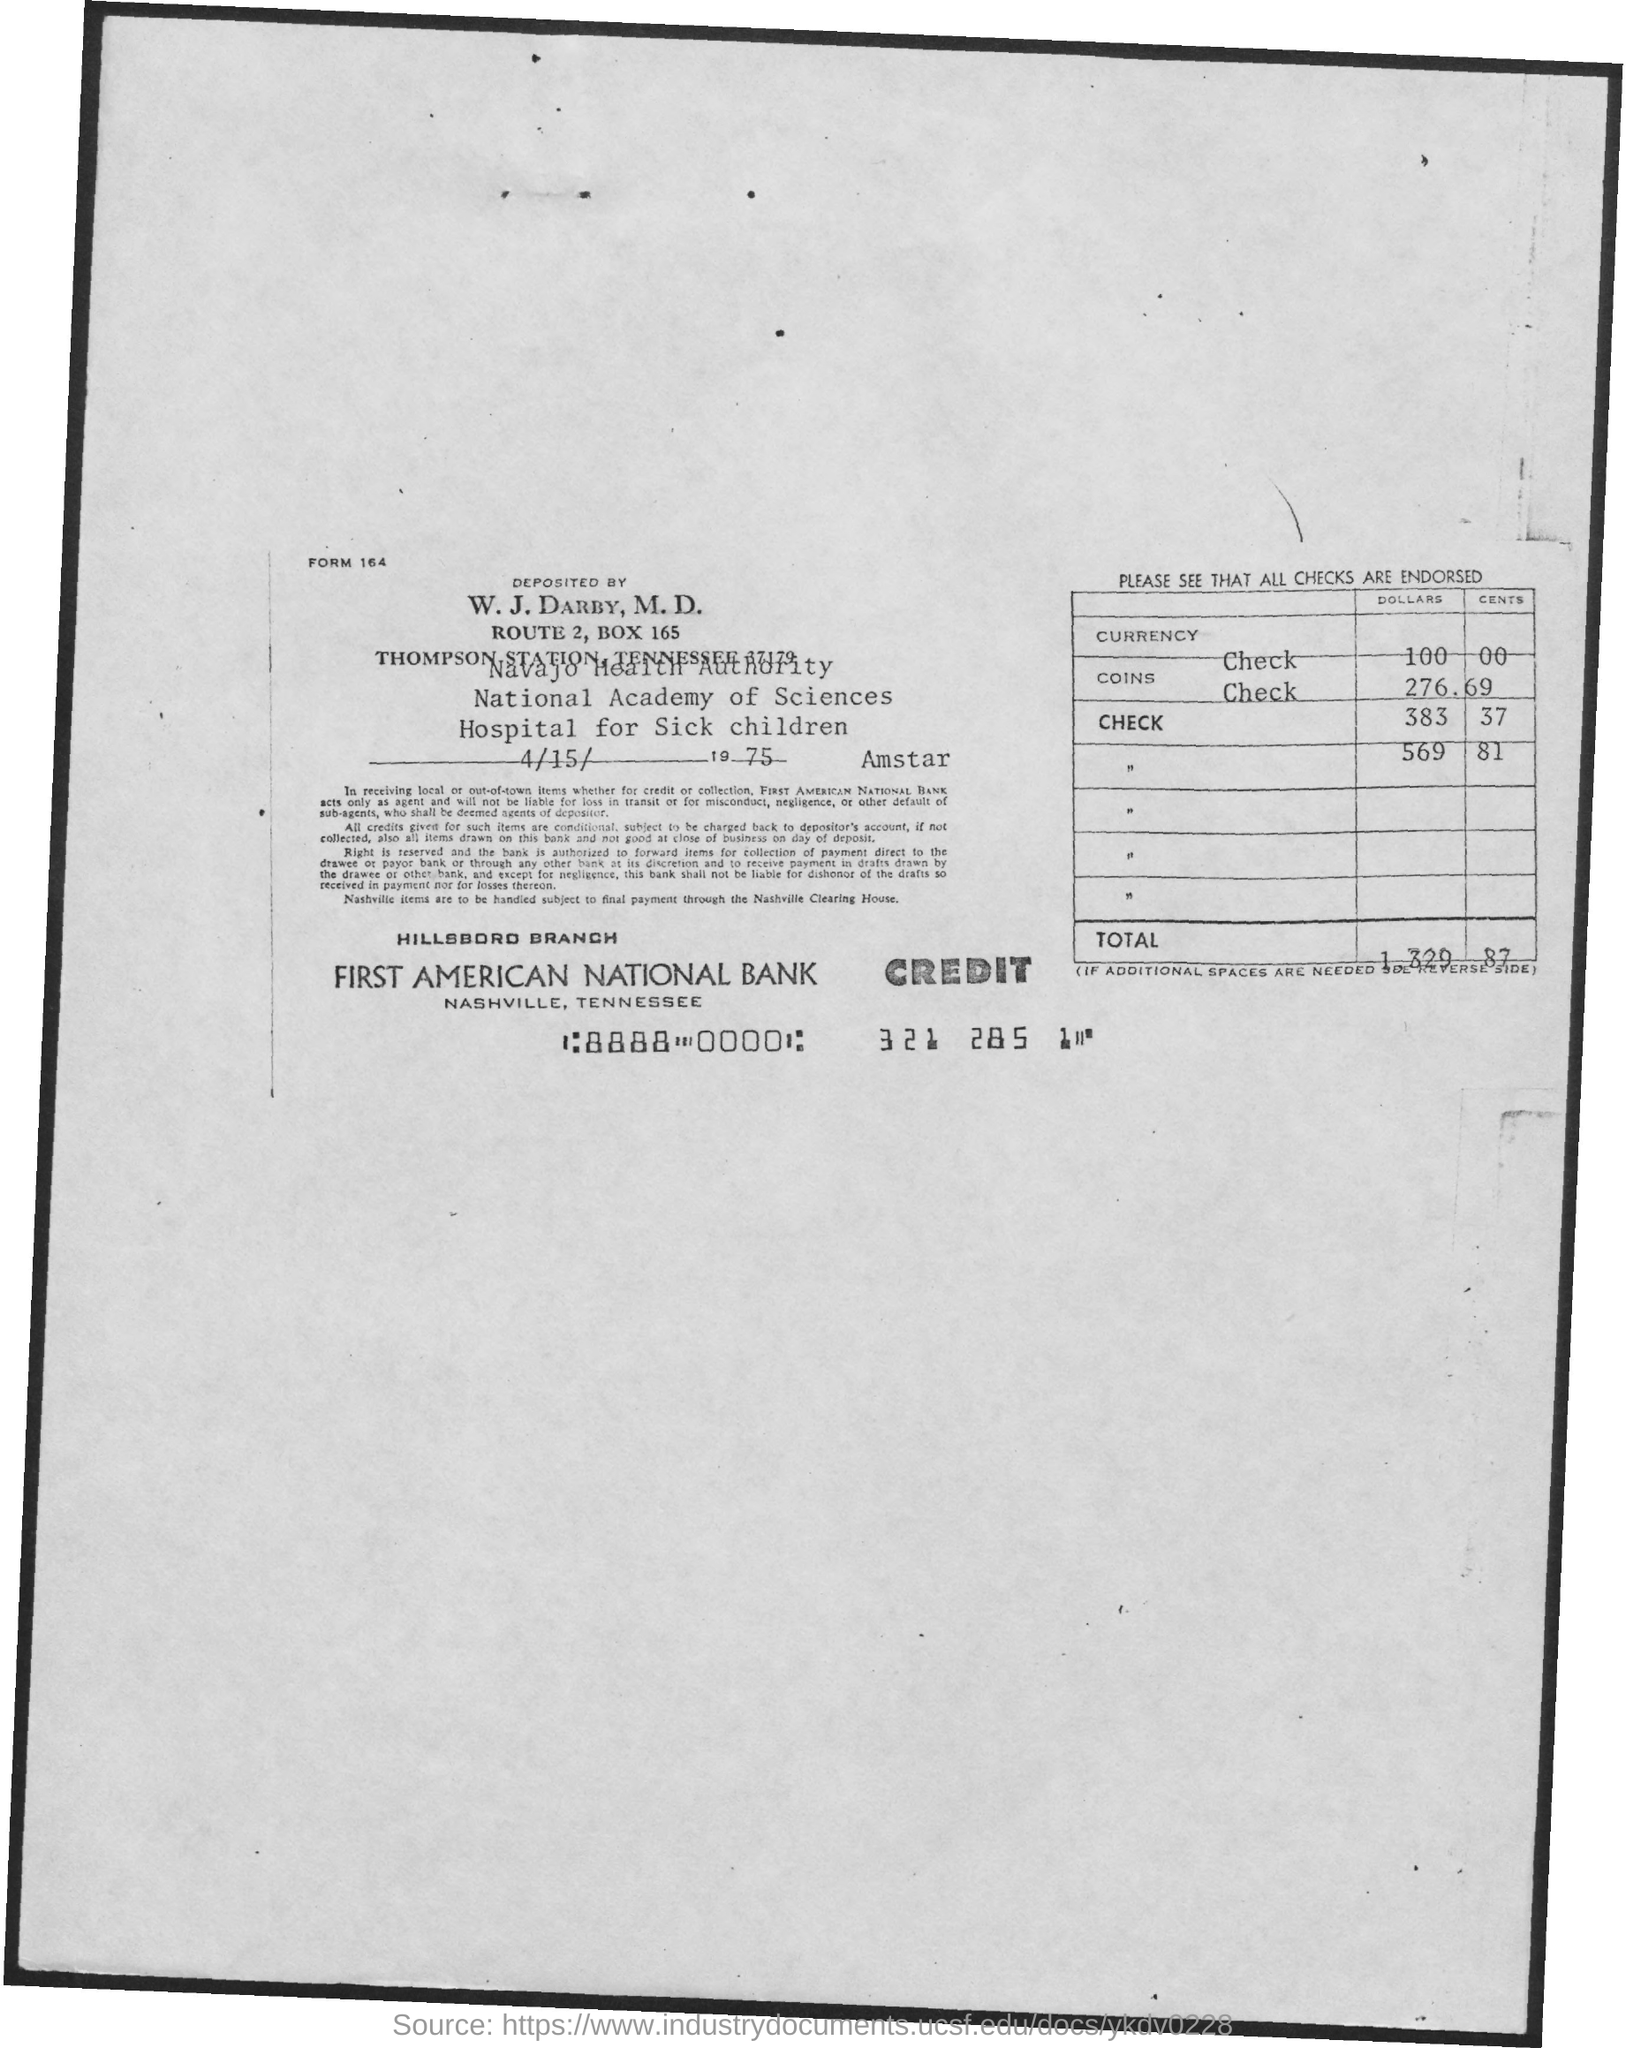Indicate a few pertinent items in this graphic. The date of deposit is April 15, 1975. The total amount of deposit is 1,329.87. The Hillsboro Branch is the name of the branch. First American National Bank is the name of the bank. What is the form number? 